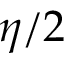Convert formula to latex. <formula><loc_0><loc_0><loc_500><loc_500>\eta / 2</formula> 